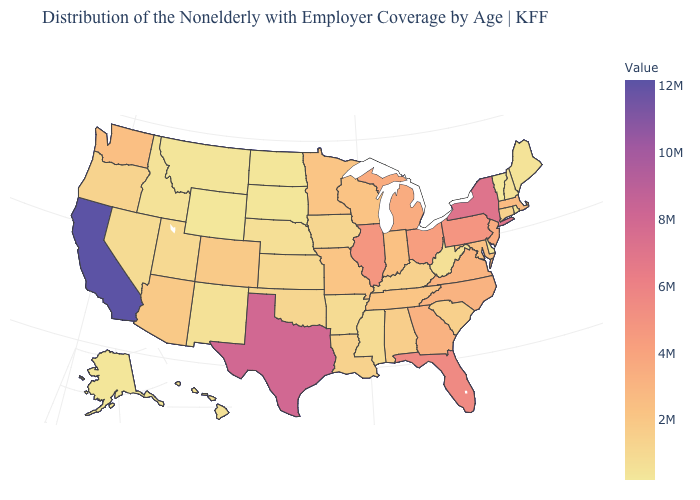Does Vermont have a higher value than Florida?
Be succinct. No. Does Delaware have the lowest value in the South?
Write a very short answer. Yes. Does Wyoming have the lowest value in the West?
Be succinct. Yes. Which states hav the highest value in the West?
Be succinct. California. Does the map have missing data?
Give a very brief answer. No. 